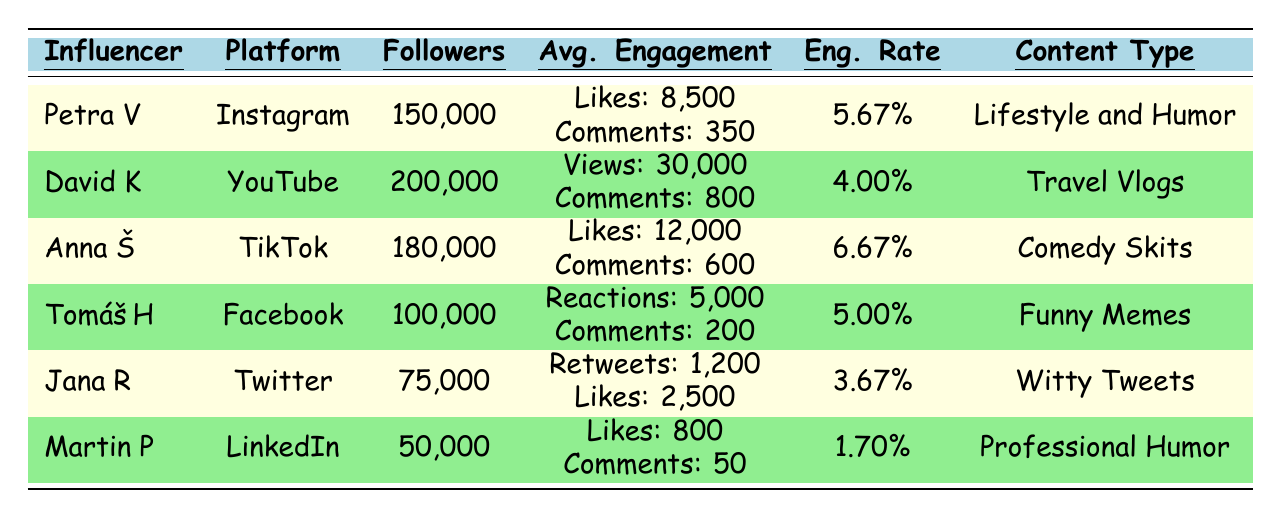What is the engagement rate of Anna Š? The engagement rate is listed in the table under the engagement rate column, and for Anna Š, it is 6.67%.
Answer: 6.67% Which influencer has the highest average likes? By comparing the average likes in the table, Anna Š has the highest with 12,000 likes.
Answer: Anna Š What is the difference in average comments between David K and Tomáš H? David K has 800 average comments, while Tomáš H has 200. The difference is 800 - 200 = 600.
Answer: 600 Which platform has the most followers among the influencers listed? The highest follower count is 200,000, attributed to David K on YouTube.
Answer: YouTube Is the engagement rate of Jana R greater than that of Martin P? Jana R has an engagement rate of 3.67%, while Martin P has 1.70%. Since 3.67% > 1.70%, the statement is true.
Answer: Yes What is the average engagement rate of all influencers listed? Adding the engagement rates (5.67 + 4.00 + 6.67 + 5.00 + 3.67 + 1.70 = 26.71) and dividing by six gives an average of 26.71 / 6 ≈ 4.45.
Answer: Approximately 4.45% Which influencer has the least number of followers? By checking the follower count, Martin P has the least with 50,000 followers.
Answer: Martin P If we combine the average likes of Petra V and Tomáš H, what is the total? Petra V has 8,500 average likes and Tomáš H has 5,000 reactions, but for likes, the focus is on Petra V’s 8,500. Adding only Petra's likes gives 8,500 + 5,000 = 13,500 combined.
Answer: 13,500 Which influencer primarily focuses on travel-related content? The table indicates that David K creates travel vlogs, focusing on travel-related content.
Answer: David K What is the total engagement (likes, comments/views) for Anna Š? For Anna Š, total engagement includes 12,000 likes and 600 comments, so the total is 12,000 + 600 = 12,600.
Answer: 12,600 